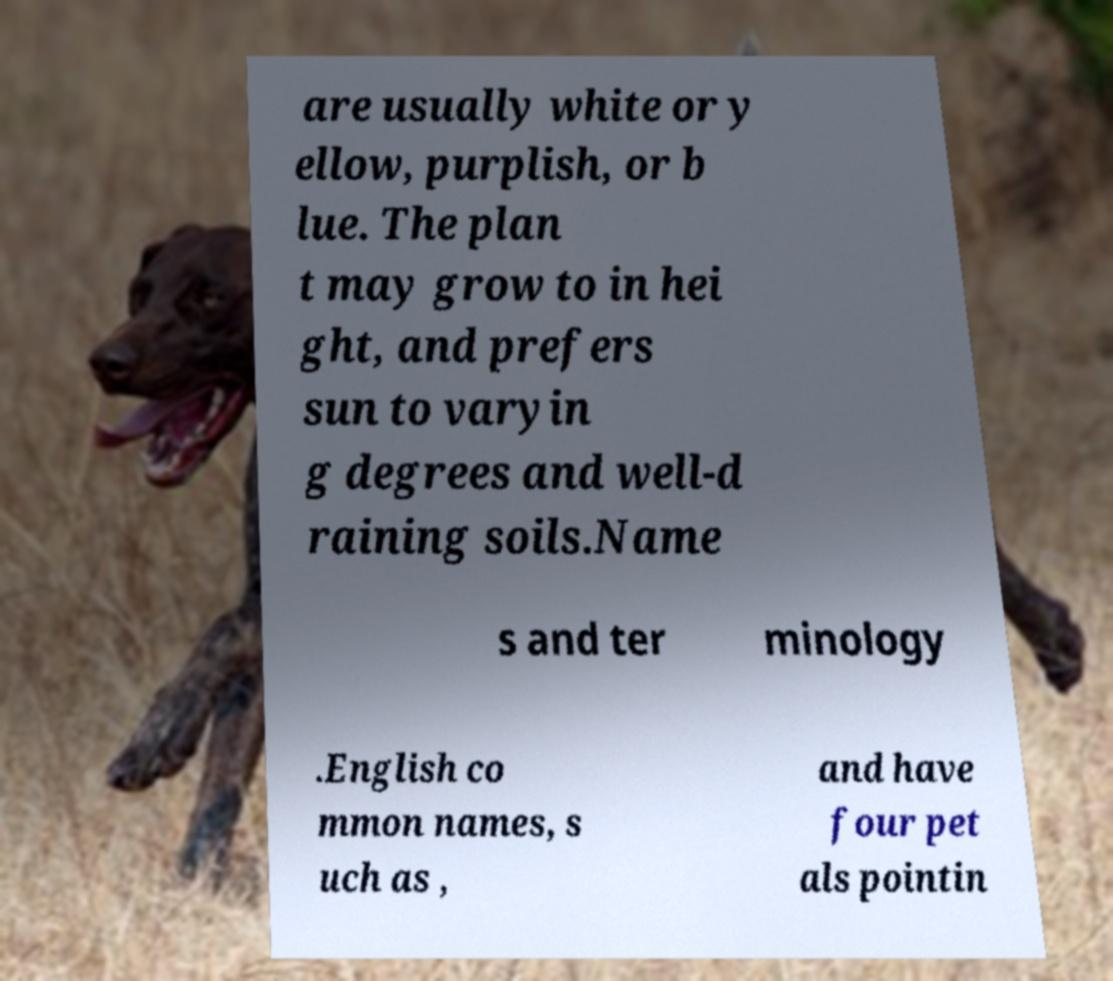Could you assist in decoding the text presented in this image and type it out clearly? are usually white or y ellow, purplish, or b lue. The plan t may grow to in hei ght, and prefers sun to varyin g degrees and well-d raining soils.Name s and ter minology .English co mmon names, s uch as , and have four pet als pointin 